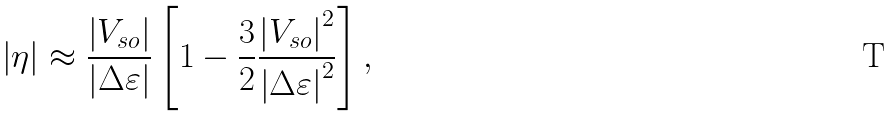<formula> <loc_0><loc_0><loc_500><loc_500>\left | \eta \right | \approx \frac { \left | V _ { s o } \right | } { \left | \Delta \varepsilon \right | } \left [ 1 - \frac { 3 } { 2 } \frac { \left | V _ { s o } \right | ^ { 2 } } { \left | \Delta \varepsilon \right | ^ { 2 } } \right ] ,</formula> 